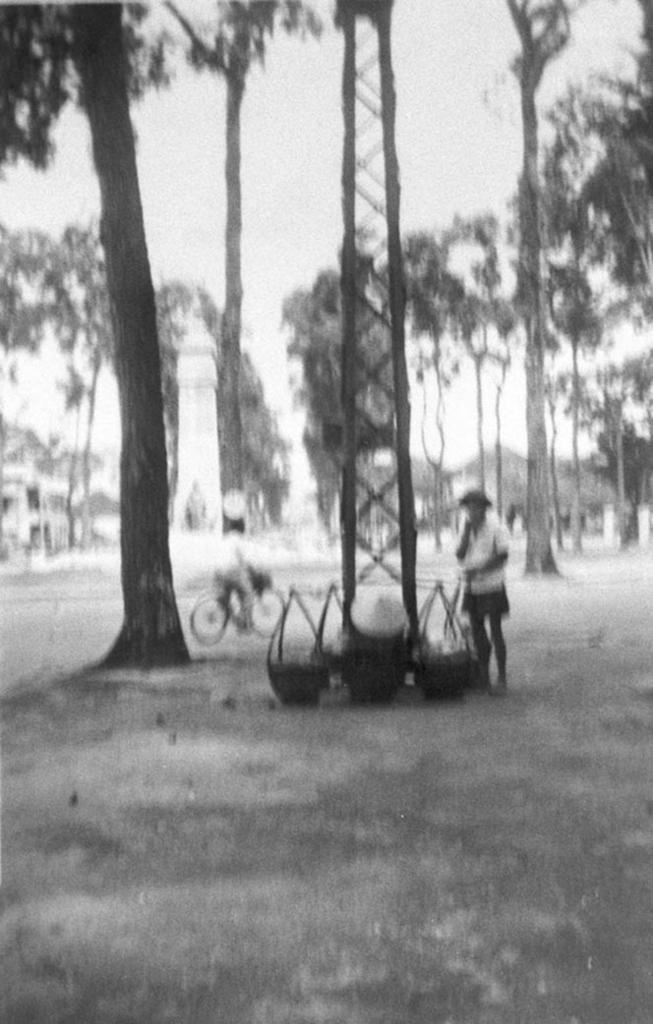Could you give a brief overview of what you see in this image? This is a black and white image. There are trees, tower, poles and baskets on the ground. I can see a person standing and another person riding a bicycle. In the background, there is the sky. 